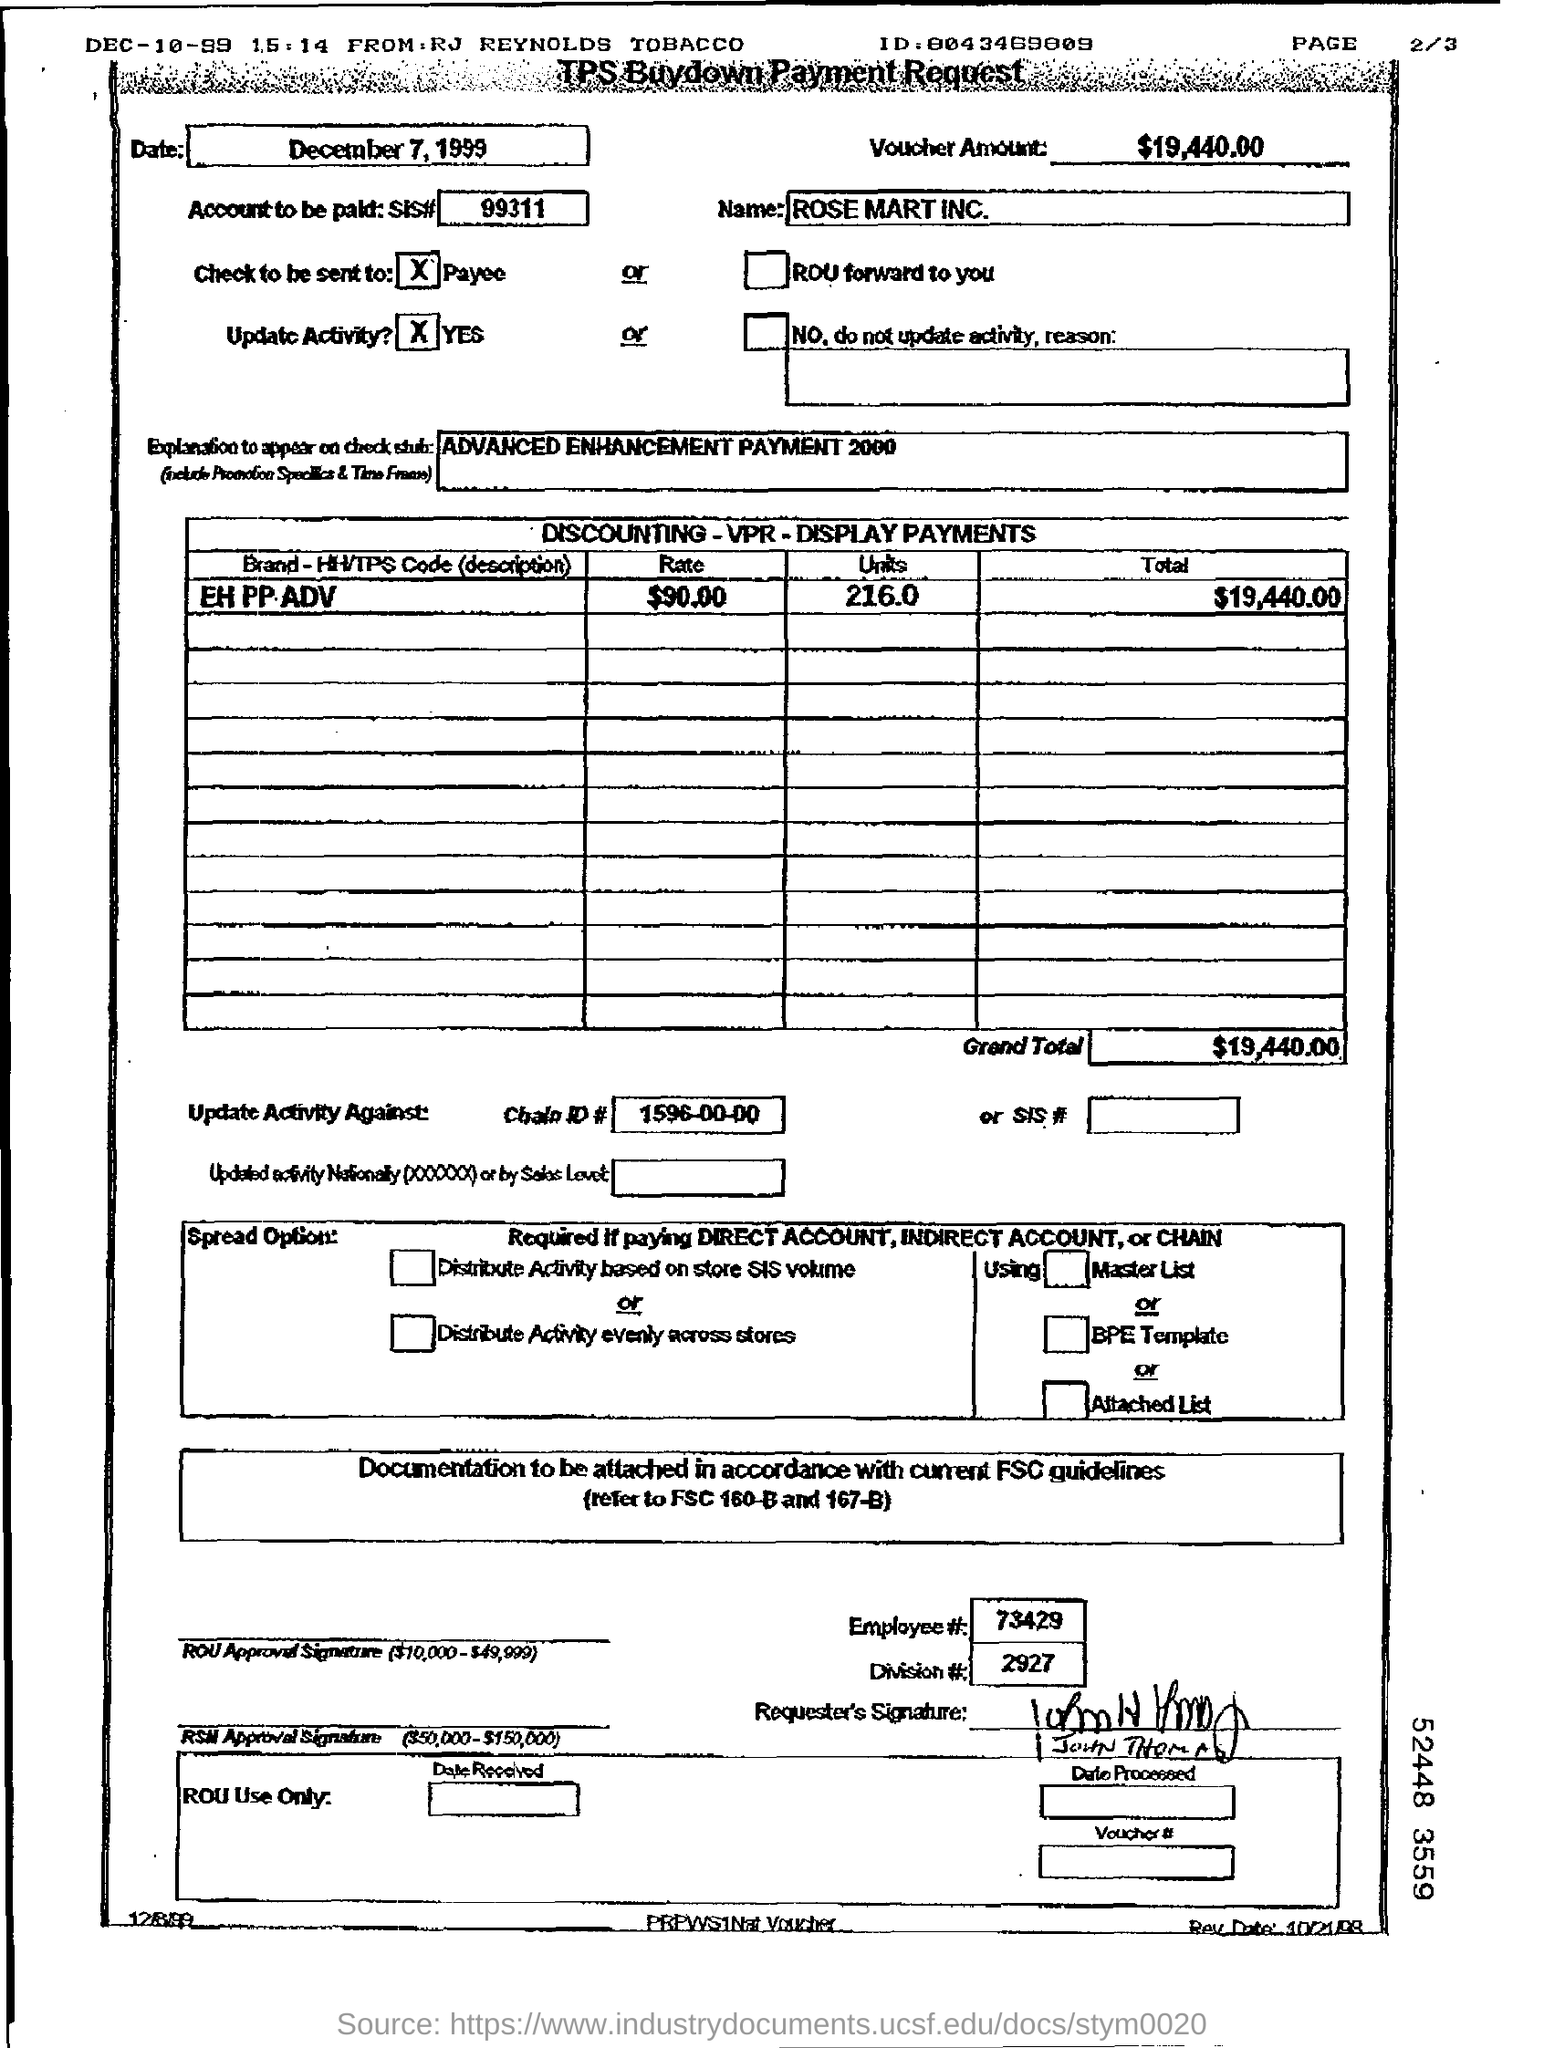Give some essential details in this illustration. The document includes a reference to "Employee #" followed by a number at the bottom of the document. The voucher amount is $19,440.00. The date written in the top left box is December 7, 1999. 